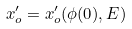<formula> <loc_0><loc_0><loc_500><loc_500>x _ { o } ^ { \prime } = x _ { o } ^ { \prime } ( \phi ( 0 ) , E )</formula> 